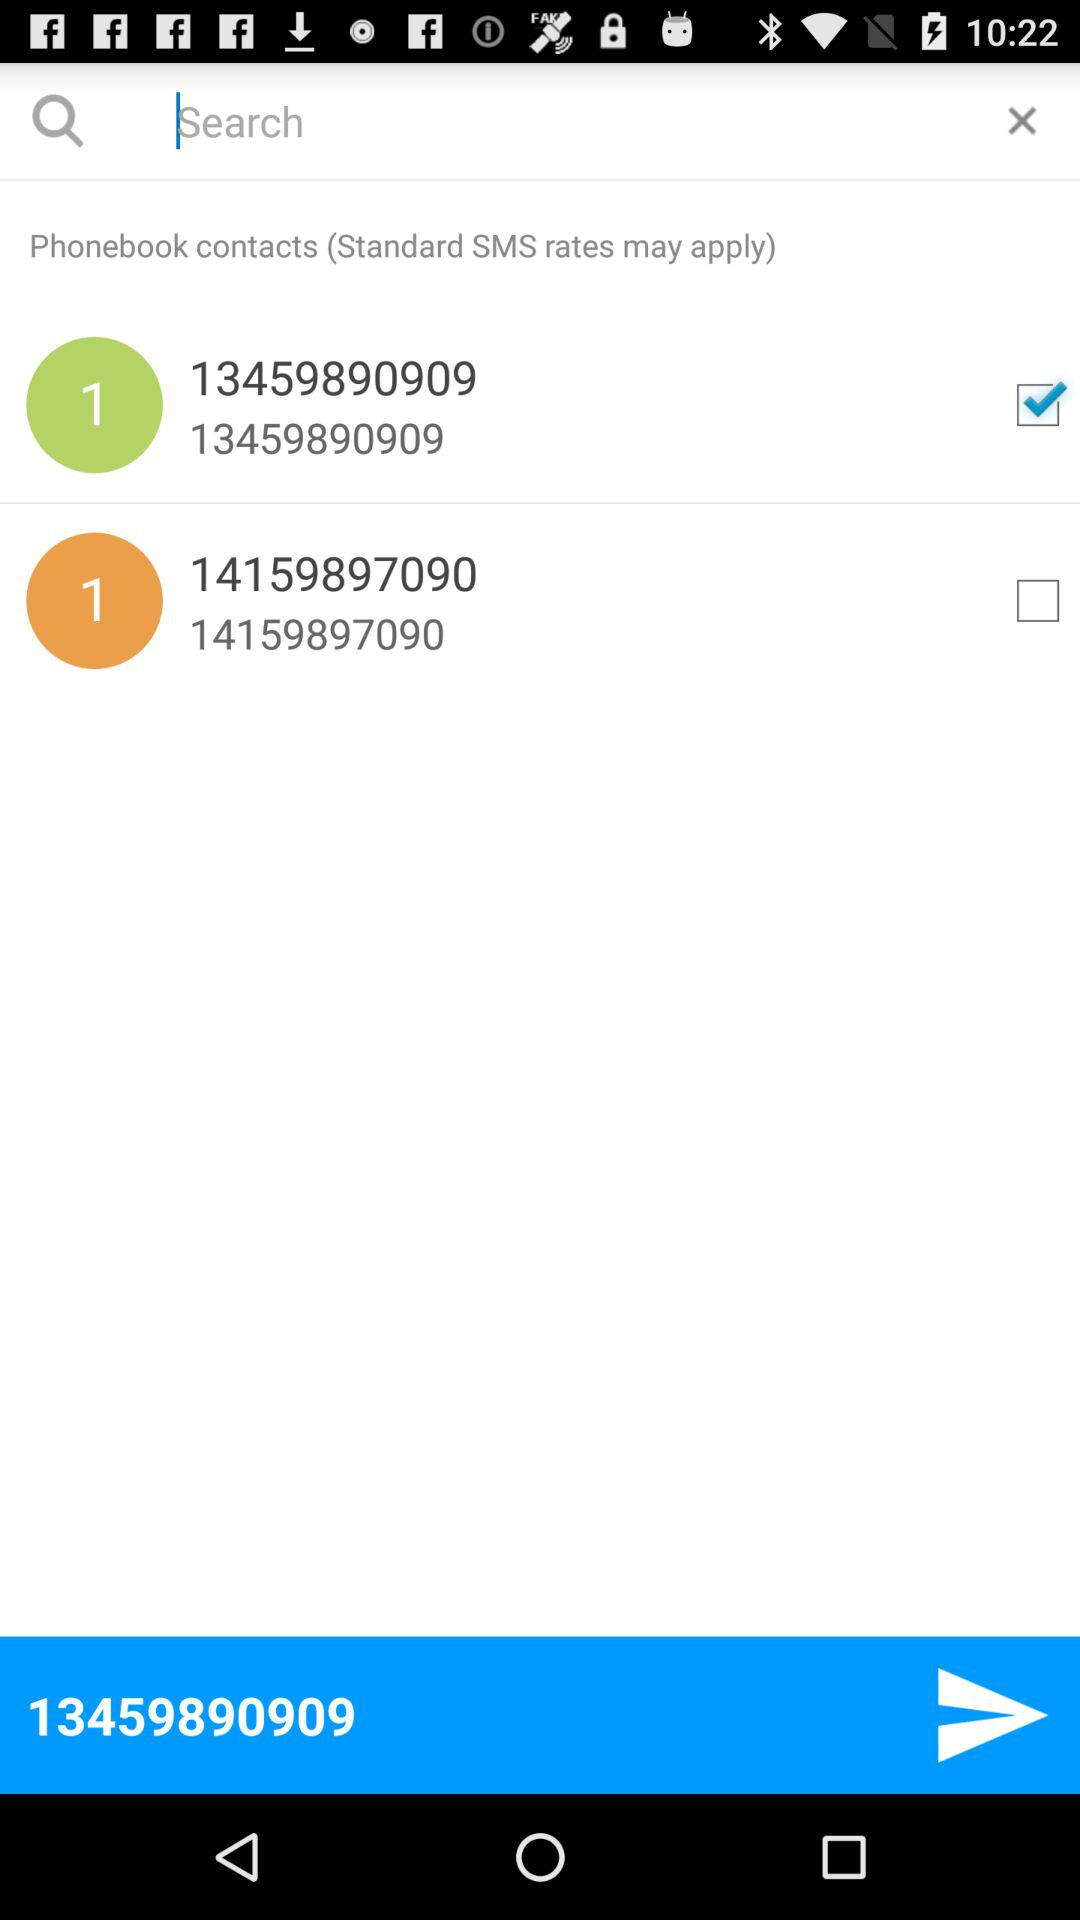How many phone numbers are there?
Answer the question using a single word or phrase. 2 